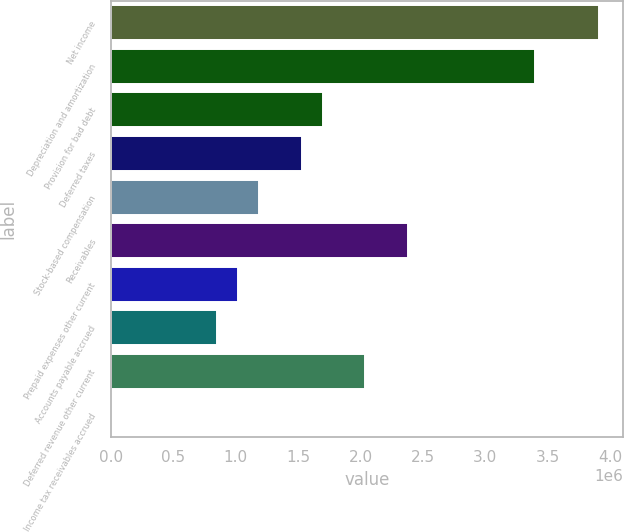Convert chart. <chart><loc_0><loc_0><loc_500><loc_500><bar_chart><fcel>Net income<fcel>Depreciation and amortization<fcel>Provision for bad debt<fcel>Deferred taxes<fcel>Stock-based compensation<fcel>Receivables<fcel>Prepaid expenses other current<fcel>Accounts payable accrued<fcel>Deferred revenue other current<fcel>Income tax receivables accrued<nl><fcel>3.90983e+06<fcel>3.39987e+06<fcel>1.7e+06<fcel>1.53001e+06<fcel>1.19004e+06<fcel>2.37995e+06<fcel>1.02005e+06<fcel>850064<fcel>2.03997e+06<fcel>129<nl></chart> 